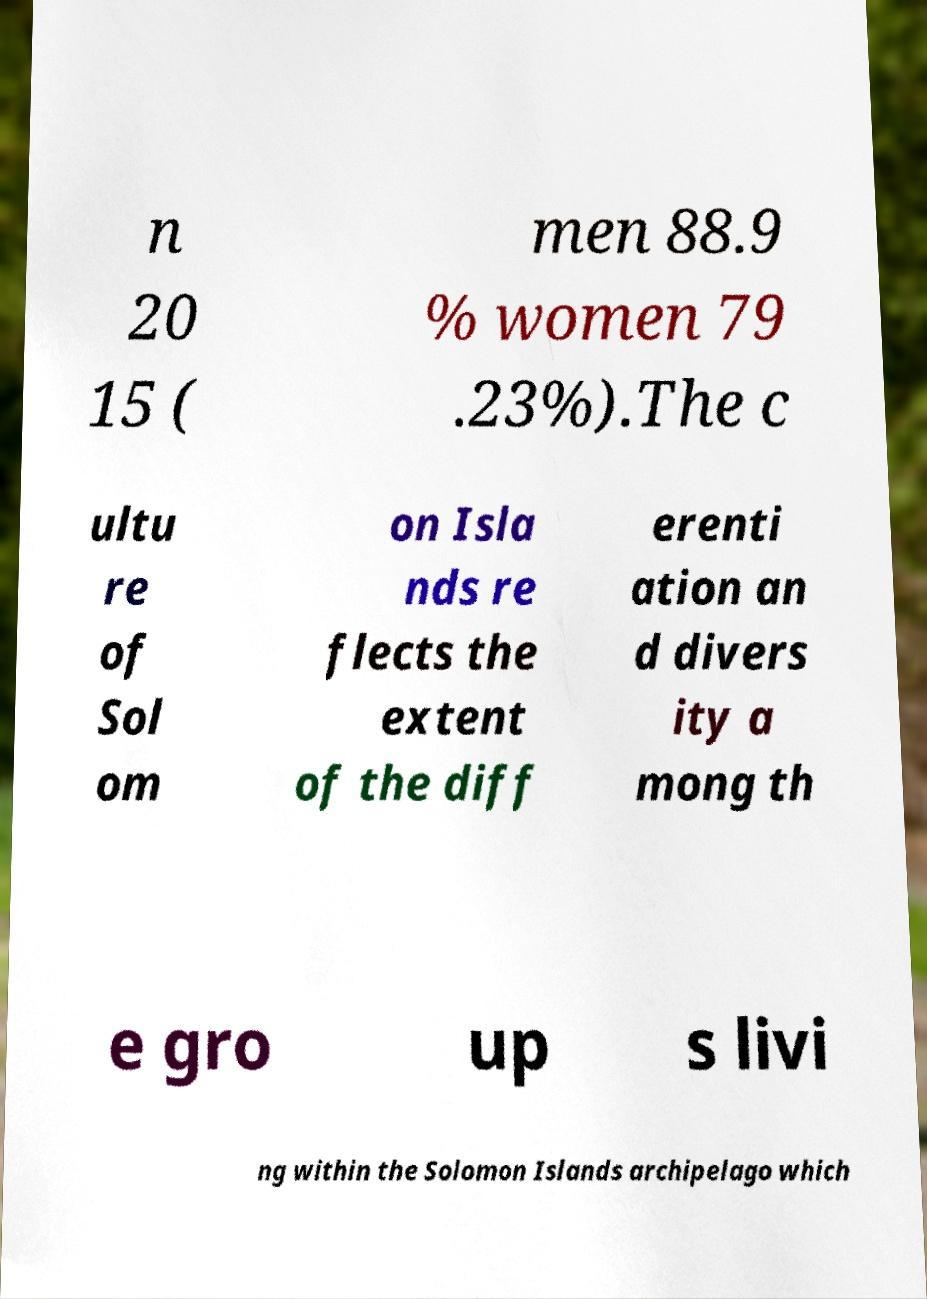There's text embedded in this image that I need extracted. Can you transcribe it verbatim? n 20 15 ( men 88.9 % women 79 .23%).The c ultu re of Sol om on Isla nds re flects the extent of the diff erenti ation an d divers ity a mong th e gro up s livi ng within the Solomon Islands archipelago which 